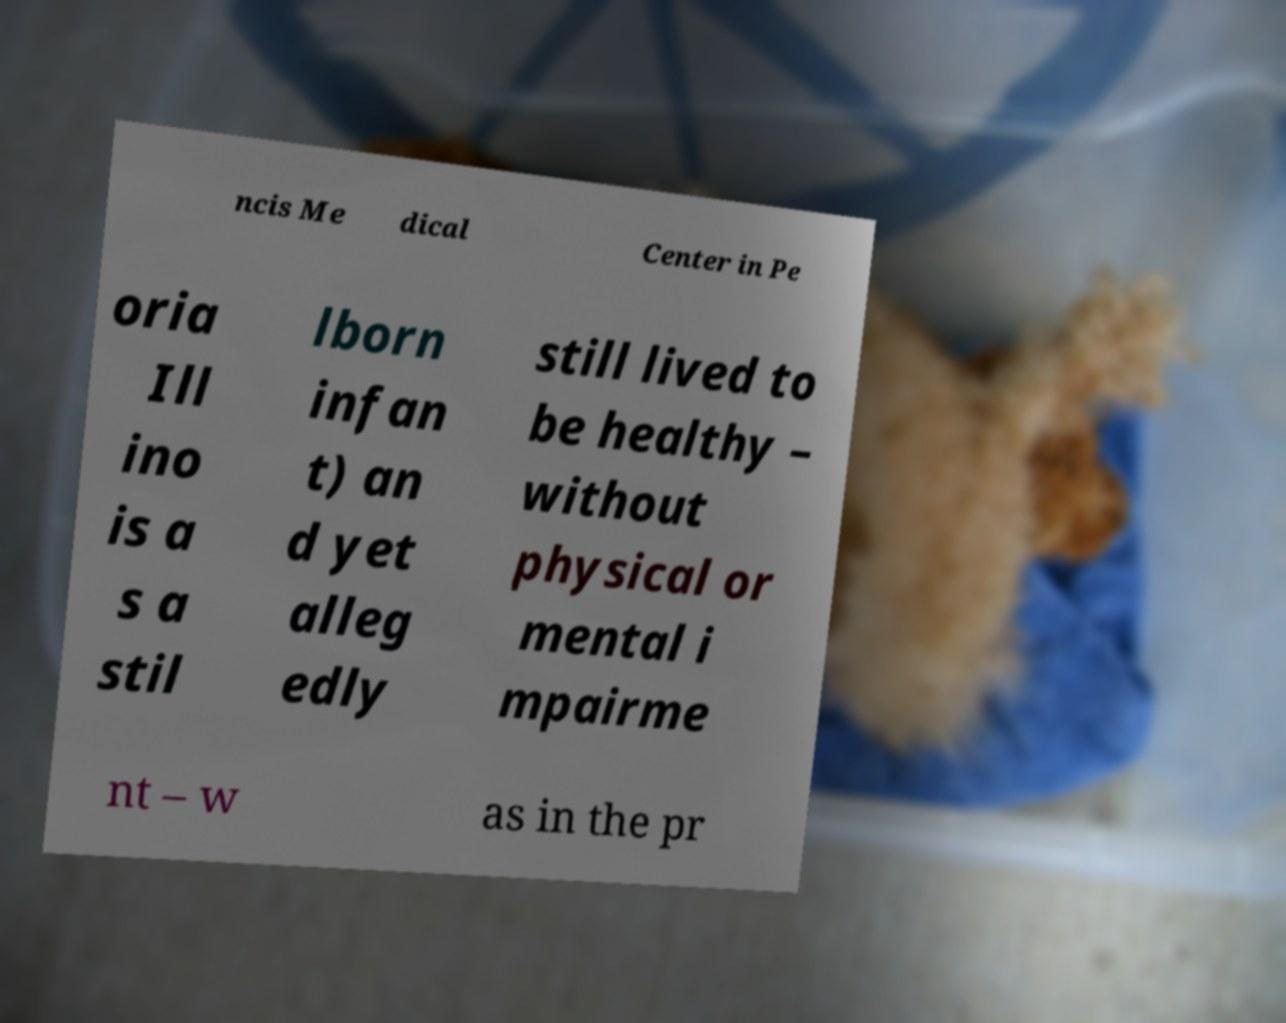Can you read and provide the text displayed in the image?This photo seems to have some interesting text. Can you extract and type it out for me? ncis Me dical Center in Pe oria Ill ino is a s a stil lborn infan t) an d yet alleg edly still lived to be healthy – without physical or mental i mpairme nt – w as in the pr 